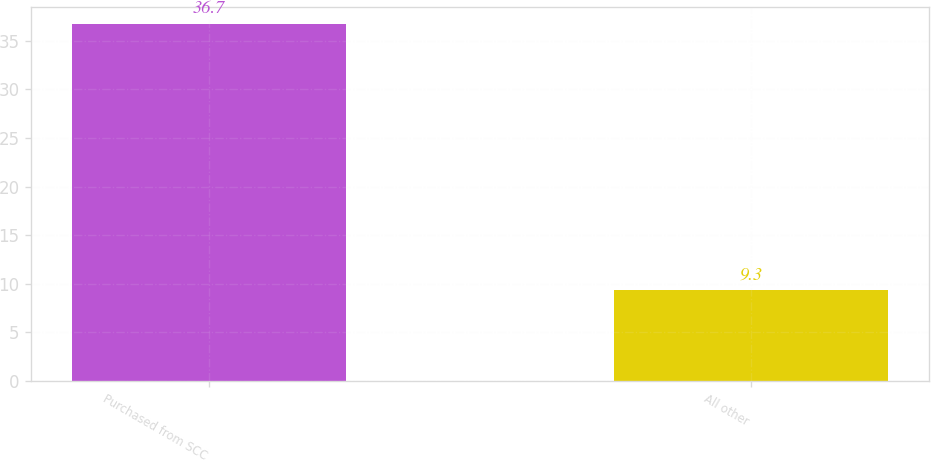Convert chart. <chart><loc_0><loc_0><loc_500><loc_500><bar_chart><fcel>Purchased from SCC<fcel>All other<nl><fcel>36.7<fcel>9.3<nl></chart> 